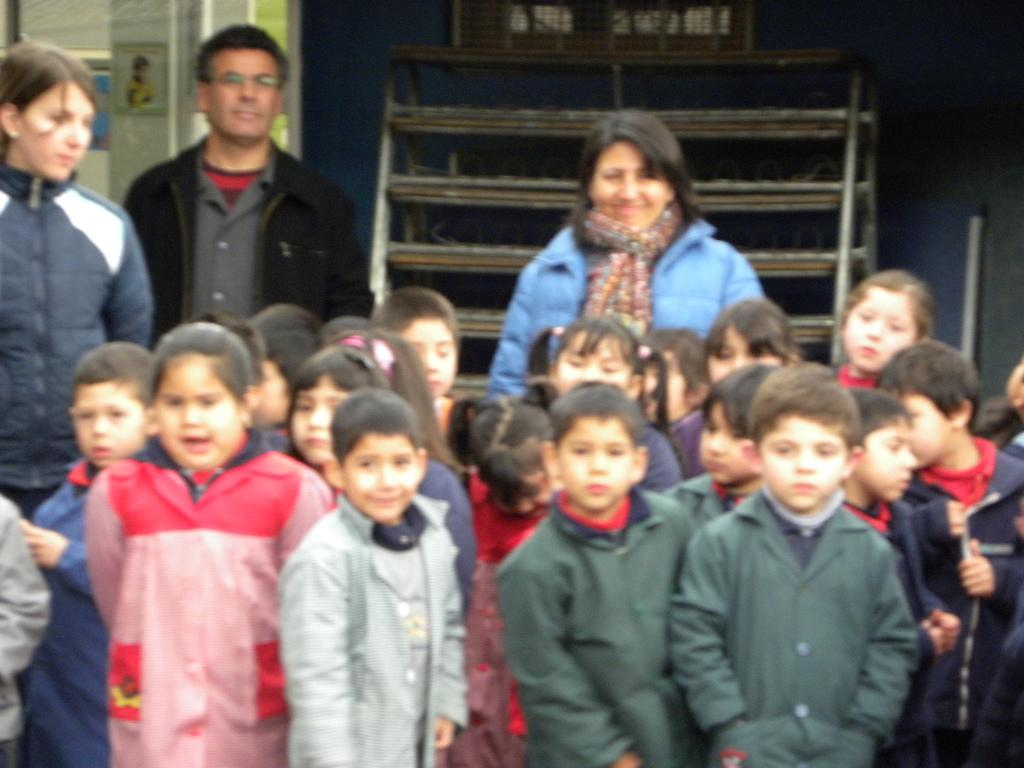Who can be seen in the image? There are kids and people standing in the image. What type of furniture is visible in the image? There are iron shelves visible in the image. What is the glass door connected to? The glass door is connected to a wall. What language are the chickens speaking in the image? There are no chickens present in the image, so it is not possible to determine what language they might be speaking. 